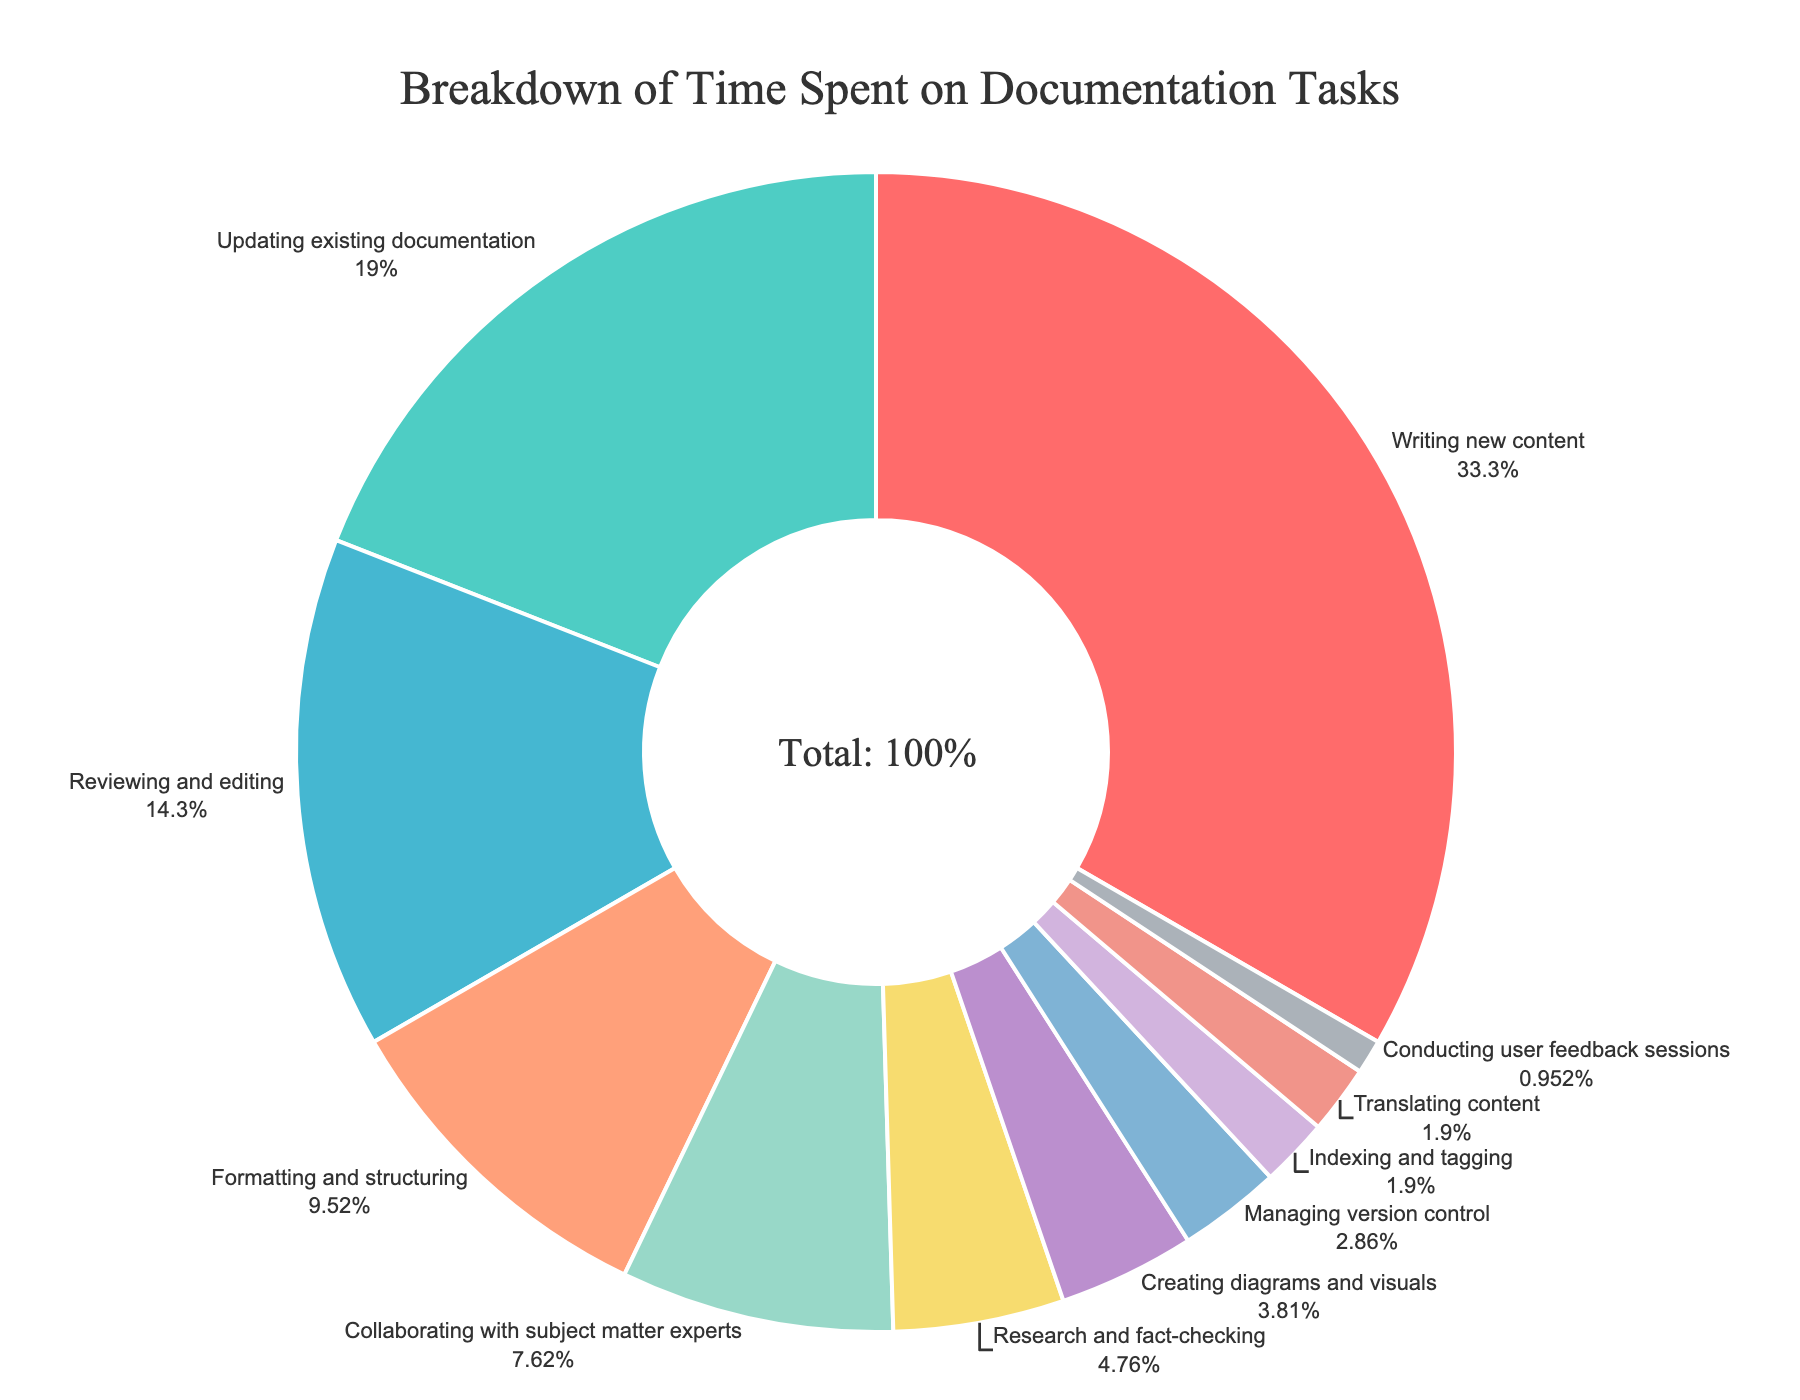what's the most time-consuming task? The most time-consuming task is the one with the highest percentage in the pie chart. Referring to the chart, "Writing new content" has the largest section.
Answer: Writing new content what's the combined percentage of tasks involving content creation (writing new content and creating diagrams and visuals)? Sum the percentages for "Writing new content" (35%) and "Creating diagrams and visuals" (4%). 35 + 4 = 39.
Answer: 39% which tasks each take up less than 5% of the time? We look at each section in the pie chart and identify those with percentages less than 5%. The tasks are "Research and fact-checking" (5%), "Creating diagrams and visuals" (4%), "Managing version control" (3%), "Indexing and tagging" (2%), "Translating content" (2%), and "Conducting user feedback sessions" (1%).
Answer: Creating diagrams and visuals, Managing version control, Indexing and tagging, Translating content, Conducting user feedback sessions how much more time is spent on writing new content compared to collaborating with subject matter experts? Subtract the percentage for "Collaborating with subject matter experts" (8%) from "Writing new content" (35%). 35 - 8 = 27.
Answer: 27% which task has the smallest percentage of time spent? Identify the smallest segment in the pie chart. "Conducting user feedback sessions" has the smallest percentage at 1%.
Answer: Conducting user feedback sessions what's the proportion of time spent on editing and reviewing compared to updating existing documentation? Divide the percentage for "Reviewing and editing" (15%) by "Updating existing documentation" (20%). 15 / 20 = 0.75.
Answer: 0.75 name the tasks that collectively make up about half of the total time. Identify tasks whose percentages add up to around 50%. "Writing new content" (35%) and "Updating existing documentation" (20%). 35 + 20 = 55, which is close to half.
Answer: Writing new content and Updating existing documentation do formatting and structuring take more time than collaborating with subject matter experts? Compare the percentages for "Formatting and structuring" (10%) and "Collaborating with subject matter experts" (8%). 10% is greater than 8%.
Answer: Yes what's the difference in time spent between the most and least time-consuming tasks? Subtract the percentage of the least time-consuming task (1% for "Conducting user feedback sessions") from the most time-consuming task (35% for "Writing new content"). 35 - 1 = 34.
Answer: 34% how many tasks take up 10% or more of the time? Count the segments with percentages of 10% or more. They are "Writing new content" (35%), "Updating existing documentation" (20%), "Reviewing and editing" (15%), and "Formatting and structuring" (10%). That's four tasks.
Answer: 4 